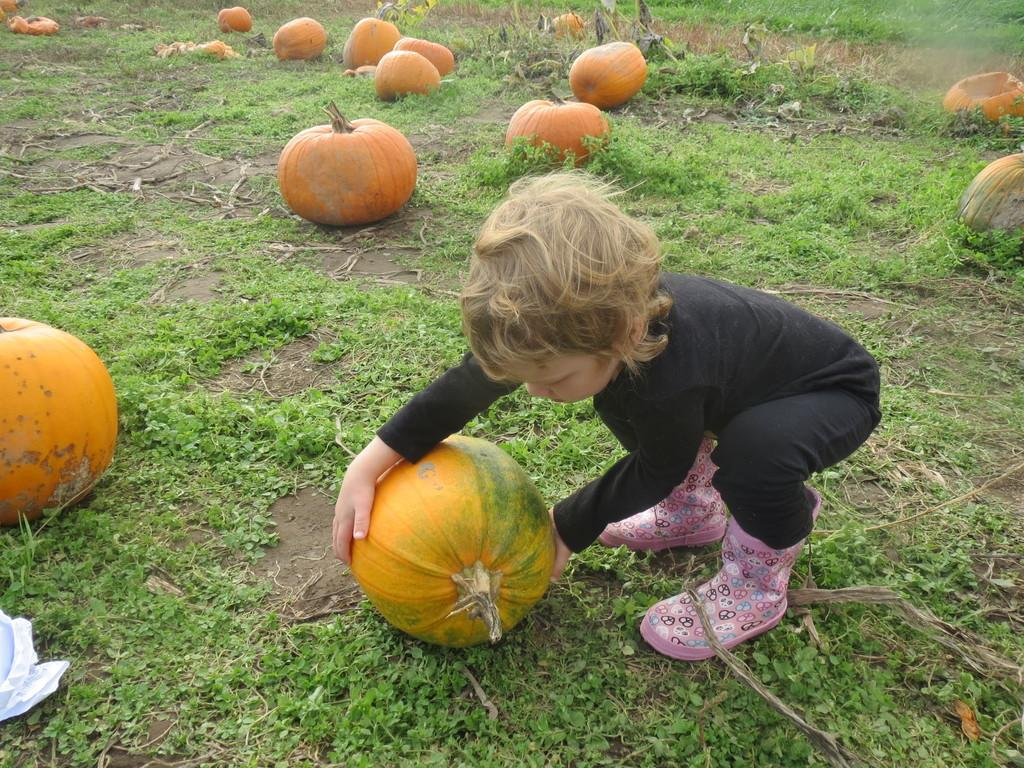What is the person in the image holding? The person is holding a pumpkin in the image. What else can be seen related to pumpkins in the image? There are pumpkins in the background of the image. What type of natural environment is visible in the background? There is grass visible in the background of the image. What other objects can be seen in the background? There are sticks in the background of the image. What type of salt can be seen in the image? There is no salt present in the image. What kind of noise is being made by the pumpkins in the image? There is no noise being made by the pumpkins in the image. 